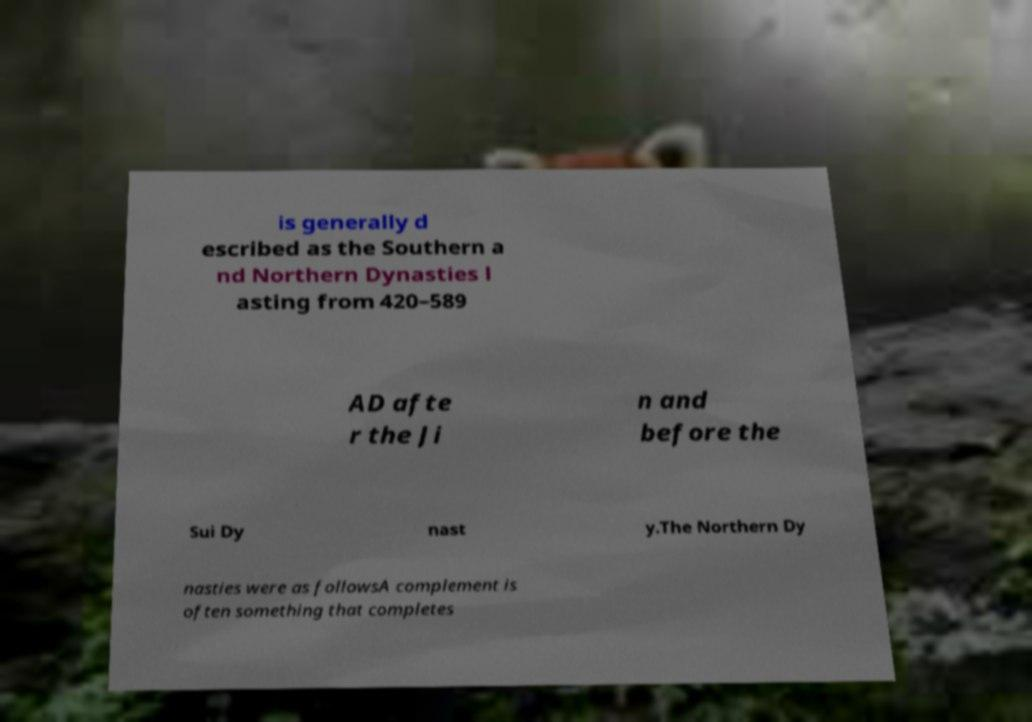Can you accurately transcribe the text from the provided image for me? is generally d escribed as the Southern a nd Northern Dynasties l asting from 420–589 AD afte r the Ji n and before the Sui Dy nast y.The Northern Dy nasties were as followsA complement is often something that completes 